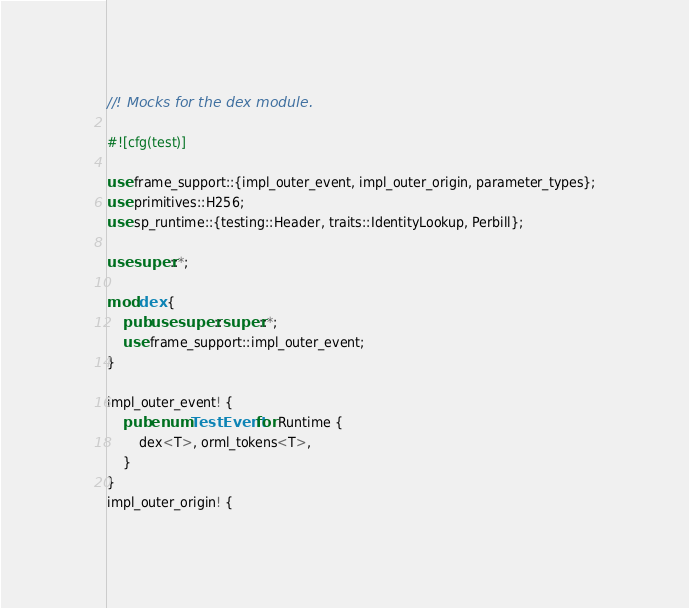<code> <loc_0><loc_0><loc_500><loc_500><_Rust_>//! Mocks for the dex module.

#![cfg(test)]

use frame_support::{impl_outer_event, impl_outer_origin, parameter_types};
use primitives::H256;
use sp_runtime::{testing::Header, traits::IdentityLookup, Perbill};

use super::*;

mod dex {
	pub use super::super::*;
	use frame_support::impl_outer_event;
}

impl_outer_event! {
	pub enum TestEvent for Runtime {
		dex<T>, orml_tokens<T>,
	}
}
impl_outer_origin! {</code> 